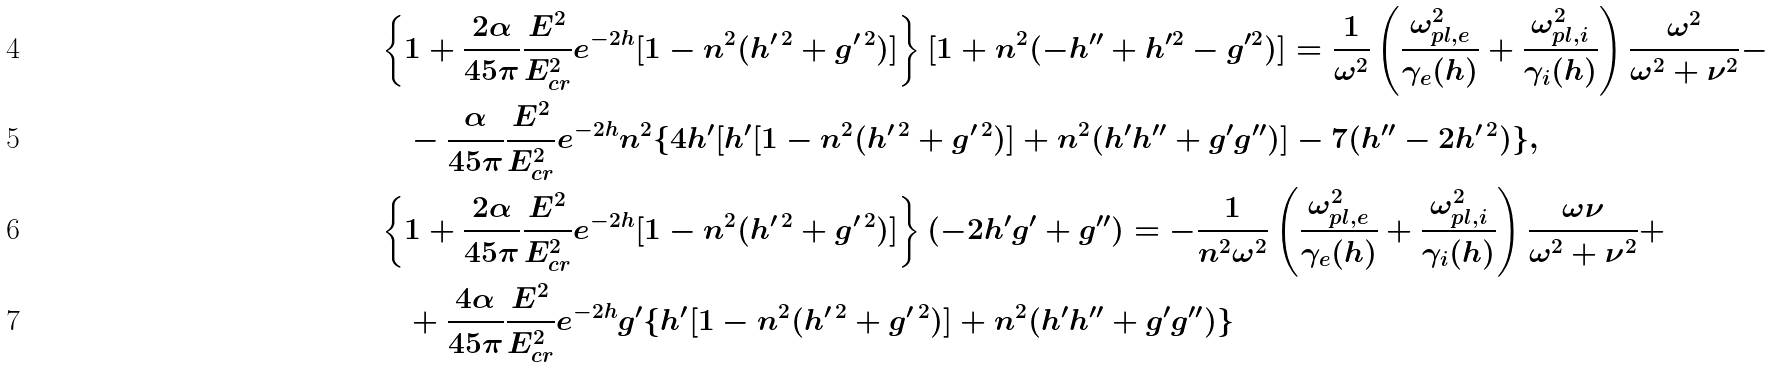<formula> <loc_0><loc_0><loc_500><loc_500>& \left \{ 1 + \frac { 2 \alpha } { 4 5 \pi } \frac { E ^ { 2 } } { E ^ { 2 } _ { c r } } e ^ { - 2 h } [ 1 - n ^ { 2 } ( h ^ { \prime \, 2 } + g ^ { \prime \, 2 } ) ] \right \} [ 1 + n ^ { 2 } ( - h ^ { \prime \prime } + h ^ { \prime 2 } - g ^ { \prime 2 } ) ] = \frac { 1 } { \omega ^ { 2 } } \left ( \frac { \omega ^ { 2 } _ { p l , e } } { \gamma _ { e } ( h ) } + \frac { \omega ^ { 2 } _ { p l , i } } { \gamma _ { i } ( h ) } \right ) \frac { \omega ^ { 2 } } { \omega ^ { 2 } + \nu ^ { 2 } } - \\ & \quad - \frac { \alpha } { 4 5 \pi } \frac { E ^ { 2 } } { E ^ { 2 } _ { c r } } e ^ { - 2 h } n ^ { 2 } \{ 4 h ^ { \prime } [ h ^ { \prime } [ 1 - n ^ { 2 } ( h ^ { \prime \, 2 } + g ^ { \prime \, 2 } ) ] + n ^ { 2 } ( h ^ { \prime } h ^ { \prime \prime } + g ^ { \prime } g ^ { \prime \prime } ) ] - 7 ( h ^ { \prime \prime } - 2 h ^ { \prime \, 2 } ) \} , \\ & \left \{ 1 + \frac { 2 \alpha } { 4 5 \pi } \frac { E ^ { 2 } } { E ^ { 2 } _ { c r } } e ^ { - 2 h } [ 1 - n ^ { 2 } ( h ^ { \prime \, 2 } + g ^ { \prime \, 2 } ) ] \right \} ( - 2 h ^ { \prime } g ^ { \prime } + g ^ { \prime \prime } ) = - \frac { 1 } { n ^ { 2 } \omega ^ { 2 } } \left ( \frac { \omega ^ { 2 } _ { p l , e } } { \gamma _ { e } ( h ) } + \frac { \omega ^ { 2 } _ { p l , i } } { \gamma _ { i } ( h ) } \right ) \frac { \omega \nu } { \omega ^ { 2 } + \nu ^ { 2 } } + \\ & \quad + \frac { 4 \alpha } { 4 5 \pi } \frac { E ^ { 2 } } { E ^ { 2 } _ { c r } } e ^ { - 2 h } g ^ { \prime } \{ h ^ { \prime } [ 1 - n ^ { 2 } ( h ^ { \prime \, 2 } + g ^ { \prime \, 2 } ) ] + n ^ { 2 } ( h ^ { \prime } h ^ { \prime \prime } + g ^ { \prime } g ^ { \prime \prime } ) \}</formula> 